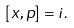<formula> <loc_0><loc_0><loc_500><loc_500>[ x , p ] = i .</formula> 